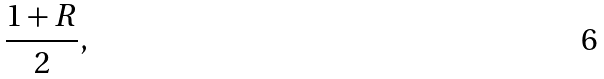Convert formula to latex. <formula><loc_0><loc_0><loc_500><loc_500>\frac { 1 + R } { 2 } ,</formula> 